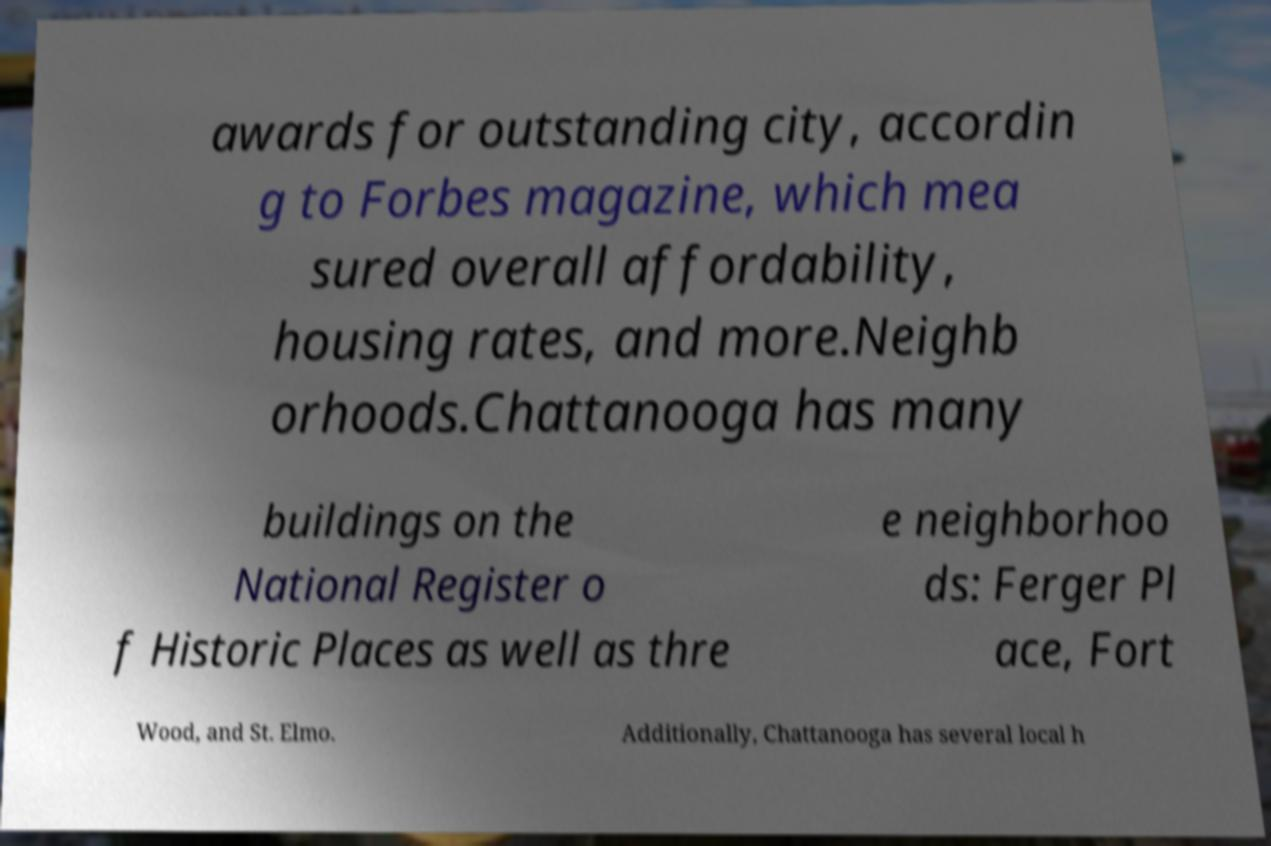There's text embedded in this image that I need extracted. Can you transcribe it verbatim? awards for outstanding city, accordin g to Forbes magazine, which mea sured overall affordability, housing rates, and more.Neighb orhoods.Chattanooga has many buildings on the National Register o f Historic Places as well as thre e neighborhoo ds: Ferger Pl ace, Fort Wood, and St. Elmo. Additionally, Chattanooga has several local h 